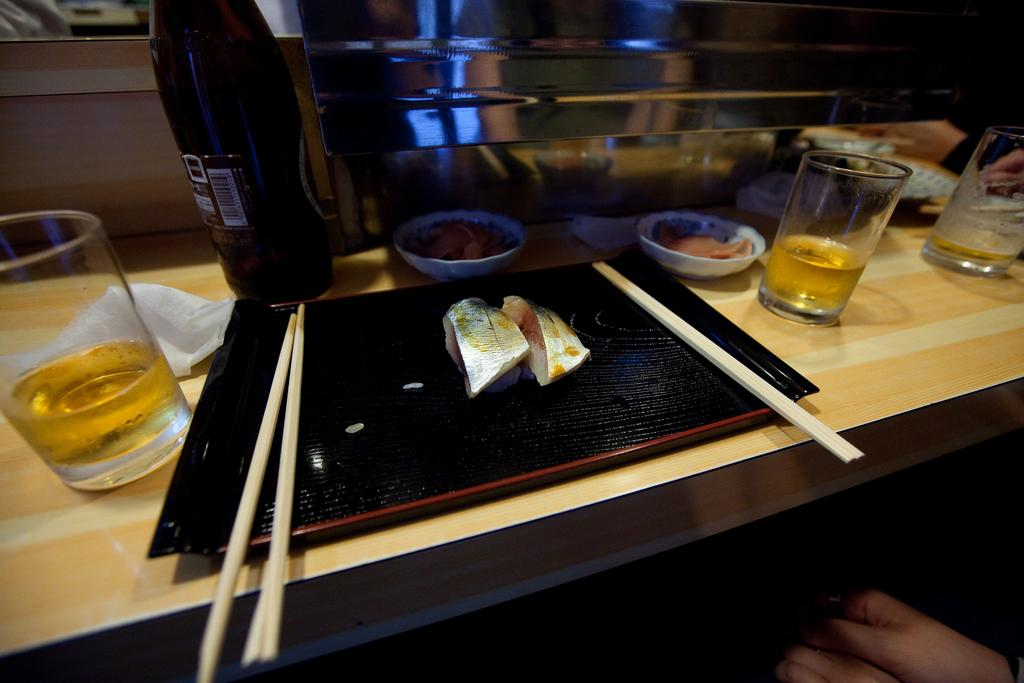What objects are on the table in the image? There are glasses, bowls, tissues, a bottle, and sticks on the table. What else can be seen on the table? There is food on the table. Who is present in the image? There is a person in front of the table. What type of art is the person creating in the image? There is no indication in the image that the person is creating any art. 